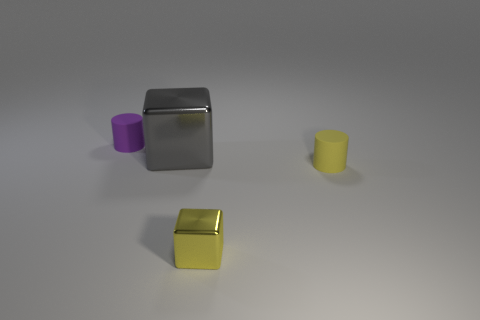Add 2 purple cylinders. How many objects exist? 6 Subtract all yellow cylinders. How many cylinders are left? 1 Subtract 0 green balls. How many objects are left? 4 Subtract 2 cubes. How many cubes are left? 0 Subtract all purple blocks. Subtract all cyan cylinders. How many blocks are left? 2 Subtract all blue spheres. How many purple cylinders are left? 1 Subtract all large objects. Subtract all small blue spheres. How many objects are left? 3 Add 1 rubber cylinders. How many rubber cylinders are left? 3 Add 3 large red metal blocks. How many large red metal blocks exist? 3 